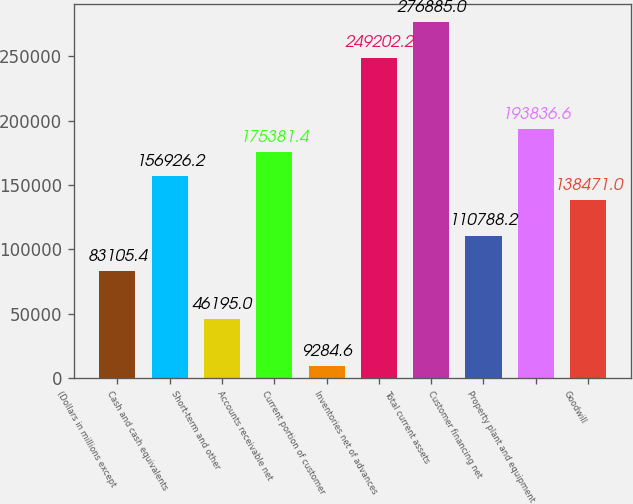Convert chart to OTSL. <chart><loc_0><loc_0><loc_500><loc_500><bar_chart><fcel>(Dollars in millions except<fcel>Cash and cash equivalents<fcel>Short-term and other<fcel>Accounts receivable net<fcel>Current portion of customer<fcel>Inventories net of advances<fcel>Total current assets<fcel>Customer financing net<fcel>Property plant and equipment<fcel>Goodwill<nl><fcel>83105.4<fcel>156926<fcel>46195<fcel>175381<fcel>9284.6<fcel>249202<fcel>276885<fcel>110788<fcel>193837<fcel>138471<nl></chart> 